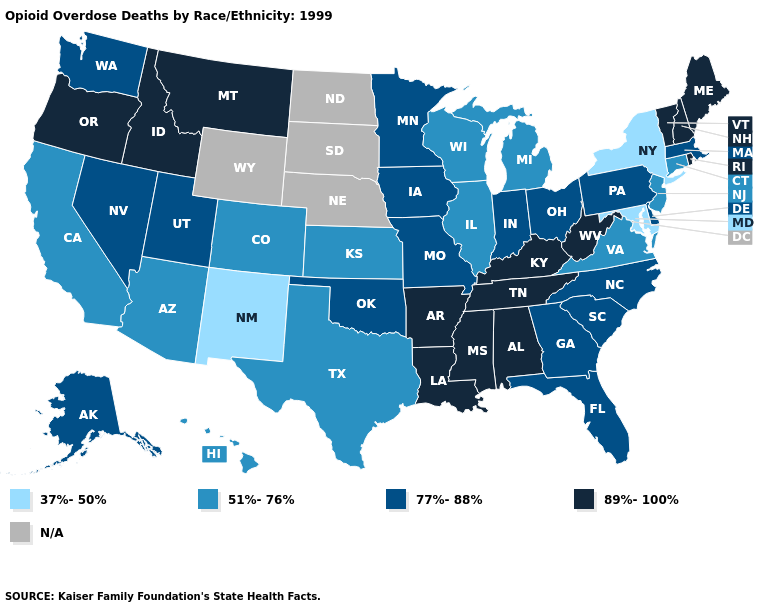Does Montana have the highest value in the West?
Write a very short answer. Yes. What is the value of Ohio?
Short answer required. 77%-88%. What is the value of Massachusetts?
Be succinct. 77%-88%. What is the lowest value in the USA?
Give a very brief answer. 37%-50%. Does the first symbol in the legend represent the smallest category?
Write a very short answer. Yes. Does Maryland have the lowest value in the USA?
Keep it brief. Yes. Does New Mexico have the lowest value in the USA?
Keep it brief. Yes. What is the value of Virginia?
Give a very brief answer. 51%-76%. Which states have the highest value in the USA?
Keep it brief. Alabama, Arkansas, Idaho, Kentucky, Louisiana, Maine, Mississippi, Montana, New Hampshire, Oregon, Rhode Island, Tennessee, Vermont, West Virginia. Among the states that border Kansas , which have the lowest value?
Keep it brief. Colorado. Name the states that have a value in the range 37%-50%?
Quick response, please. Maryland, New Mexico, New York. Name the states that have a value in the range N/A?
Concise answer only. Nebraska, North Dakota, South Dakota, Wyoming. Does the map have missing data?
Concise answer only. Yes. Name the states that have a value in the range N/A?
Write a very short answer. Nebraska, North Dakota, South Dakota, Wyoming. 